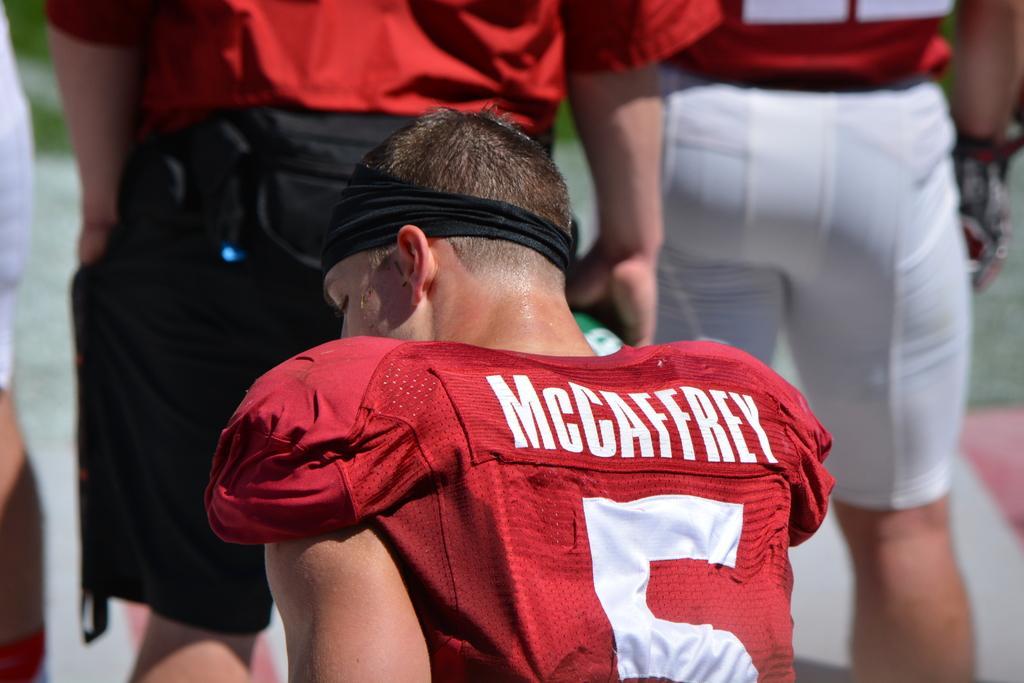Could you give a brief overview of what you see in this image? In this image I can see people. These people are wearing red color clothes. The background of the image is blurred. 